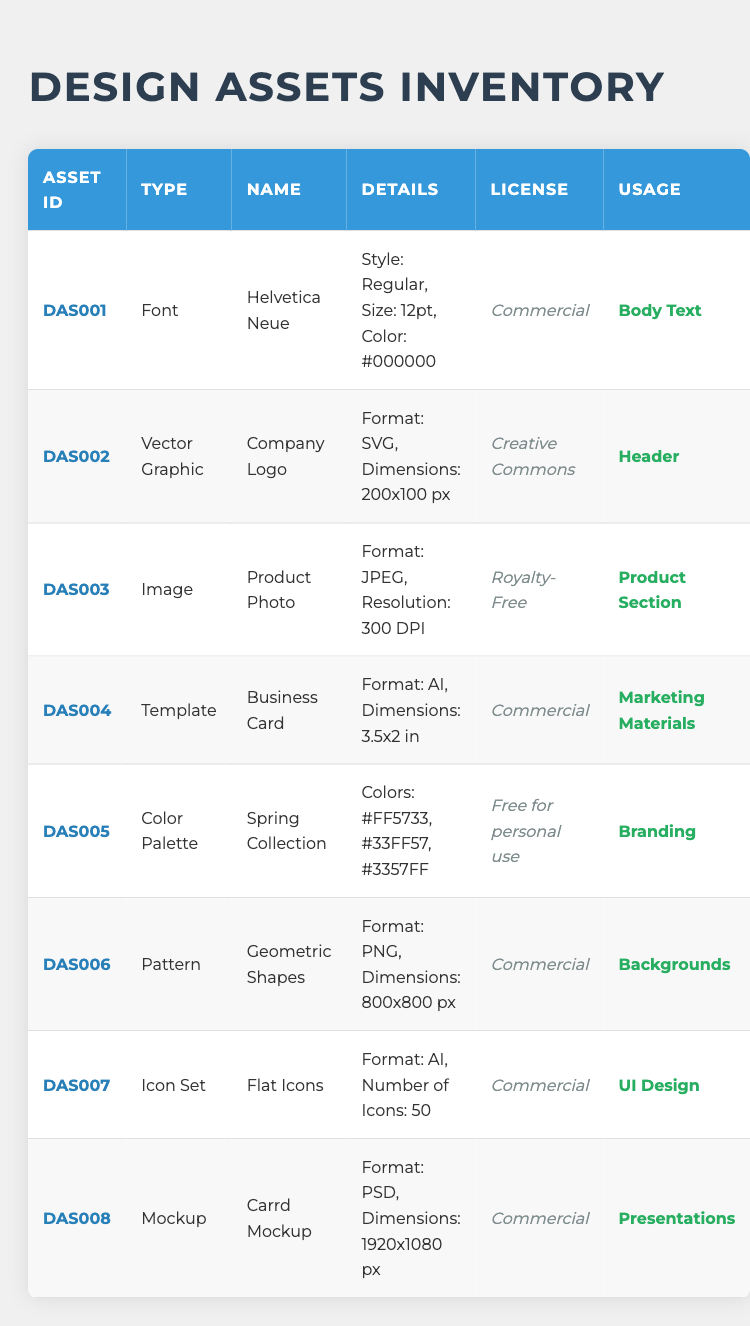What is the name of the asset with ID DAS004? By looking at the table, I find the asset with ID DAS004 listed in the first column, and the corresponding asset name in the third column is "Business Card."
Answer: Business Card How many vector graphics are listed in the inventory? I need to count the rows where the asset type is "Vector Graphic." I find one entry: the "Company Logo" asset (DAS002).
Answer: 1 Is the license for the "Product Photo" asset commercial? I look at the row for the "Product Photo" (DAS003) and see that the license is "Royalty-Free," which is not commercial.
Answer: No What is the format of the "Flat Icons" asset? I check the row for the "Flat Icons" (DAS007) in the table, where I find that the format is listed as "AI."
Answer: AI Which asset is used for backgrounds and what is its license? I identify from the table that the asset used for backgrounds is "Geometric Shapes" (DAS006) and its license is "Commercial."
Answer: Geometric Shapes, Commercial How many colors are included in the "Spring Collection" palette? By looking at the details of the "Spring Collection" (DAS005), I see that there are three colors listed: #FF5733, #33FF57, and #3357FF. So, I count them to find that there are 3 colors.
Answer: 3 Which asset has the highest resolution and what is it? I review the different assets to see which one has the highest resolution. The "Product Photo" (DAS003) has a resolution of "300 DPI," while other images do not specify a higher resolution. Thus, it is the highest.
Answer: Product Photo, 300 DPI Are there any assets related to branding in the inventory? Looking at the usage column, I find the "Spring Collection" (DAS005) is specifically mentioned for “Branding.” Thus, there is one asset related to branding.
Answer: Yes Which asset has the largest dimensions and what are those dimensions? I compare the dimensions from the assets listed. The "Carrd Mockup" (DAS008) has dimensions of "1920x1080 px," which is larger than the other dimensions mentioned in the inventory.
Answer: Carrd Mockup, 1920x1080 px 